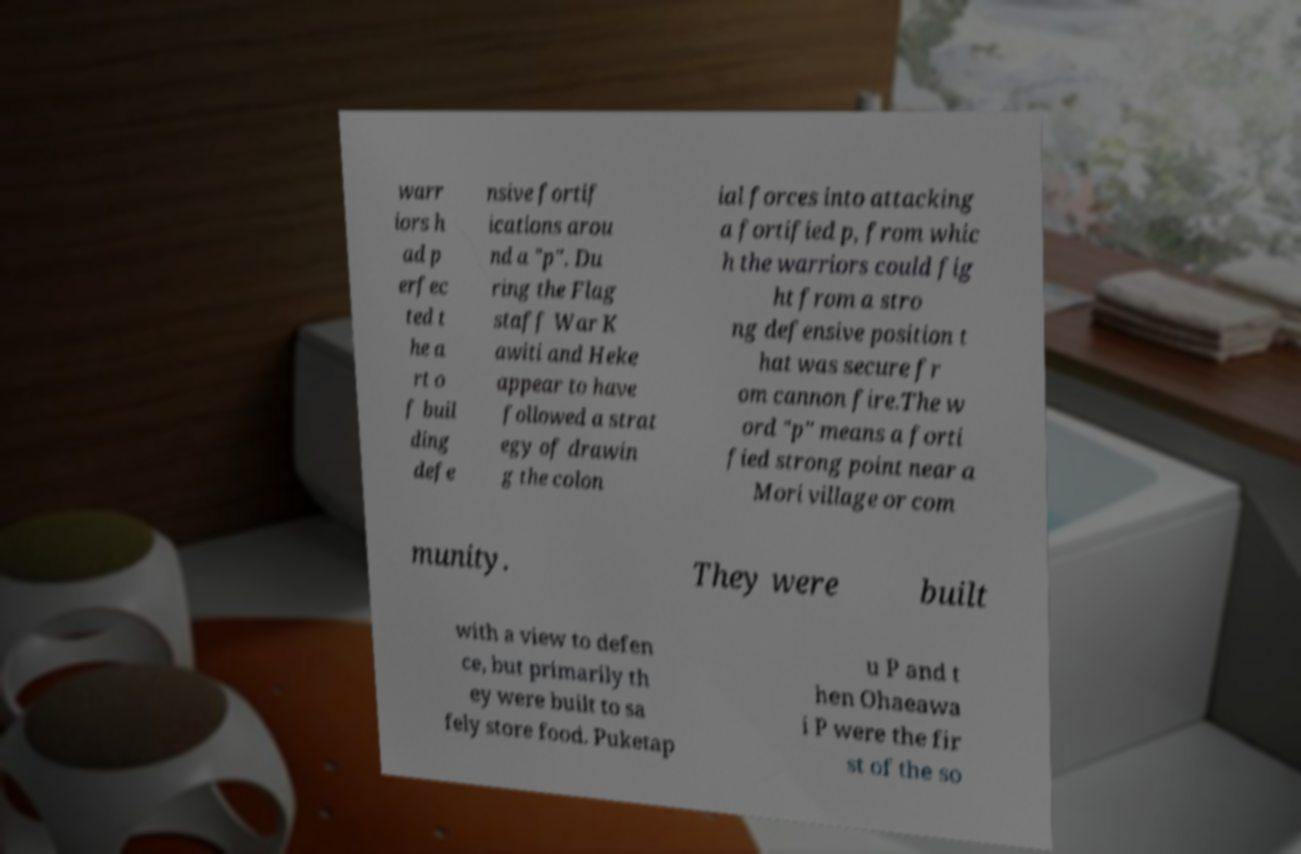Could you extract and type out the text from this image? warr iors h ad p erfec ted t he a rt o f buil ding defe nsive fortif ications arou nd a "p". Du ring the Flag staff War K awiti and Heke appear to have followed a strat egy of drawin g the colon ial forces into attacking a fortified p, from whic h the warriors could fig ht from a stro ng defensive position t hat was secure fr om cannon fire.The w ord "p" means a forti fied strong point near a Mori village or com munity. They were built with a view to defen ce, but primarily th ey were built to sa fely store food. Puketap u P and t hen Ohaeawa i P were the fir st of the so 